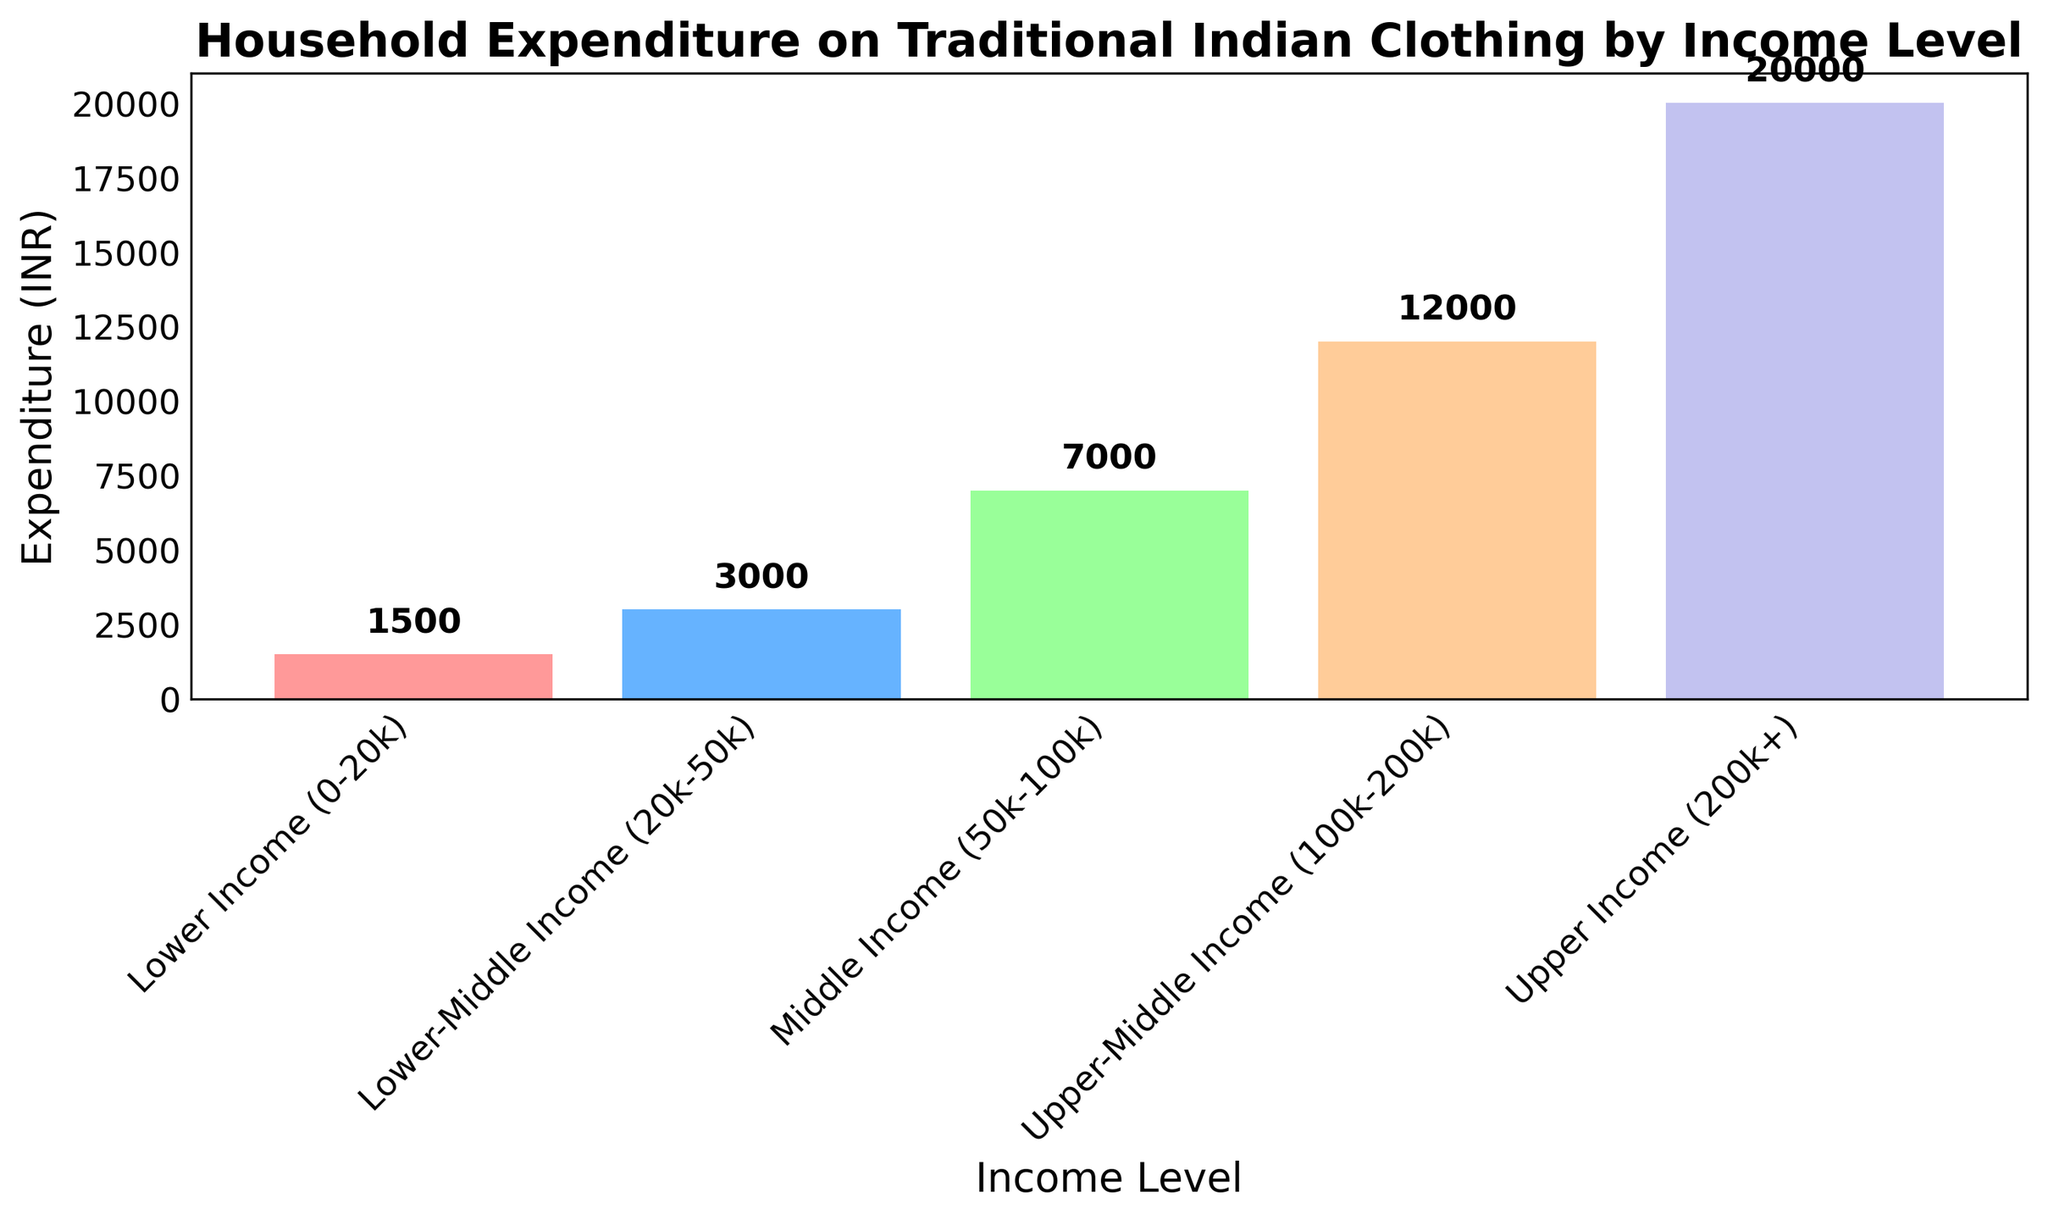How much more do Upper-Income households spend on traditional Indian clothing compared to Lower-Middle Income households? First, find the expenditure of Upper-Income households, which is 20000 INR. Then, find the expenditure of Lower-Middle Income households, which is 3000 INR. Subtract the latter from the former: 20000 - 3000 = 17000.
Answer: 17000 INR Which income group spends the least on traditional Indian clothing? Look at the heights of the bars for each income group. The bar for "Lower Income (0-20k)" is the shortest, indicating it has the smallest expenditure.
Answer: Lower Income (0-20k) What is the total expenditure on traditional Indian clothing by Lower Income and Lower-Middle Income households combined? Find the expenditures for both income groups: Lower Income (1500 INR) and Lower-Middle Income (3000 INR). Sum these values: 1500 + 3000 = 4500.
Answer: 4500 INR Is the expenditure on traditional Indian clothing by Upper-Middle Income households more than twice that of Lower-Middle Income households? First, calculate twice the expenditure of Lower-Middle Income households: 3000 * 2 = 6000. Compare this with the expenditure of Upper-Middle Income households, which is 12000 INR. Since 12000 is greater than 6000, the answer is yes.
Answer: Yes Which two income groups have the closest expenditures on traditional Indian clothing? Examine the heights of the bars and compare the expenditure values. "Lower-Middle Income (20k-50k)" has 3000 INR and "Lower Income (0-20k)" has 1500 INR. The difference between them is 3000 - 1500 = 1500 INR, which is the smallest difference compared to other pairs.
Answer: Lower Income (0-20k) and Lower-Middle Income (20k-50k) By how much does the expenditure on traditional Indian clothing increase from Lower Income to Upper-Middle Income? Find the expenditure values for both income groups: Lower Income (1500 INR) and Upper-Middle Income (12000 INR). Subtract the former from the latter: 12000 - 1500 = 10500.
Answer: 10500 INR What is the average expenditure on traditional Indian clothing across all income levels? Sum the expenditures of all income groups: 1500 + 3000 + 7000 + 12000 + 20000 = 43500 INR. Divide by the number of groups, which is 5: 43500 / 5 = 8700.
Answer: 8700 INR Which income group has the second highest expenditure on traditional Indian clothing? The heights of the bars show "Upper Income (200k+)" as the highest (20000 INR). The next highest is "Upper-Middle Income (100k-200k)" with 12000 INR.
Answer: Upper-Middle Income (100k-200k) Are there any income levels with equal expenditure on traditional Indian clothing? Check the heights of the bars and the corresponding values. All expenditure values are different: 1500, 3000, 7000, 12000, and 20000 INR.
Answer: No Which income group spends three times as much on traditional Indian clothing as the Lower-Middle Income group? The expenditure of Lower-Middle Income (20k-50k) is 3000 INR. Calculate three times this amount: 3000 * 3 = 9000. Compare this with other groups and find that no group matches exactly. However, "Middle Income (50k-100k)" spends 7000 INR, which is the closest but not equal to three times 3000.
Answer: None 